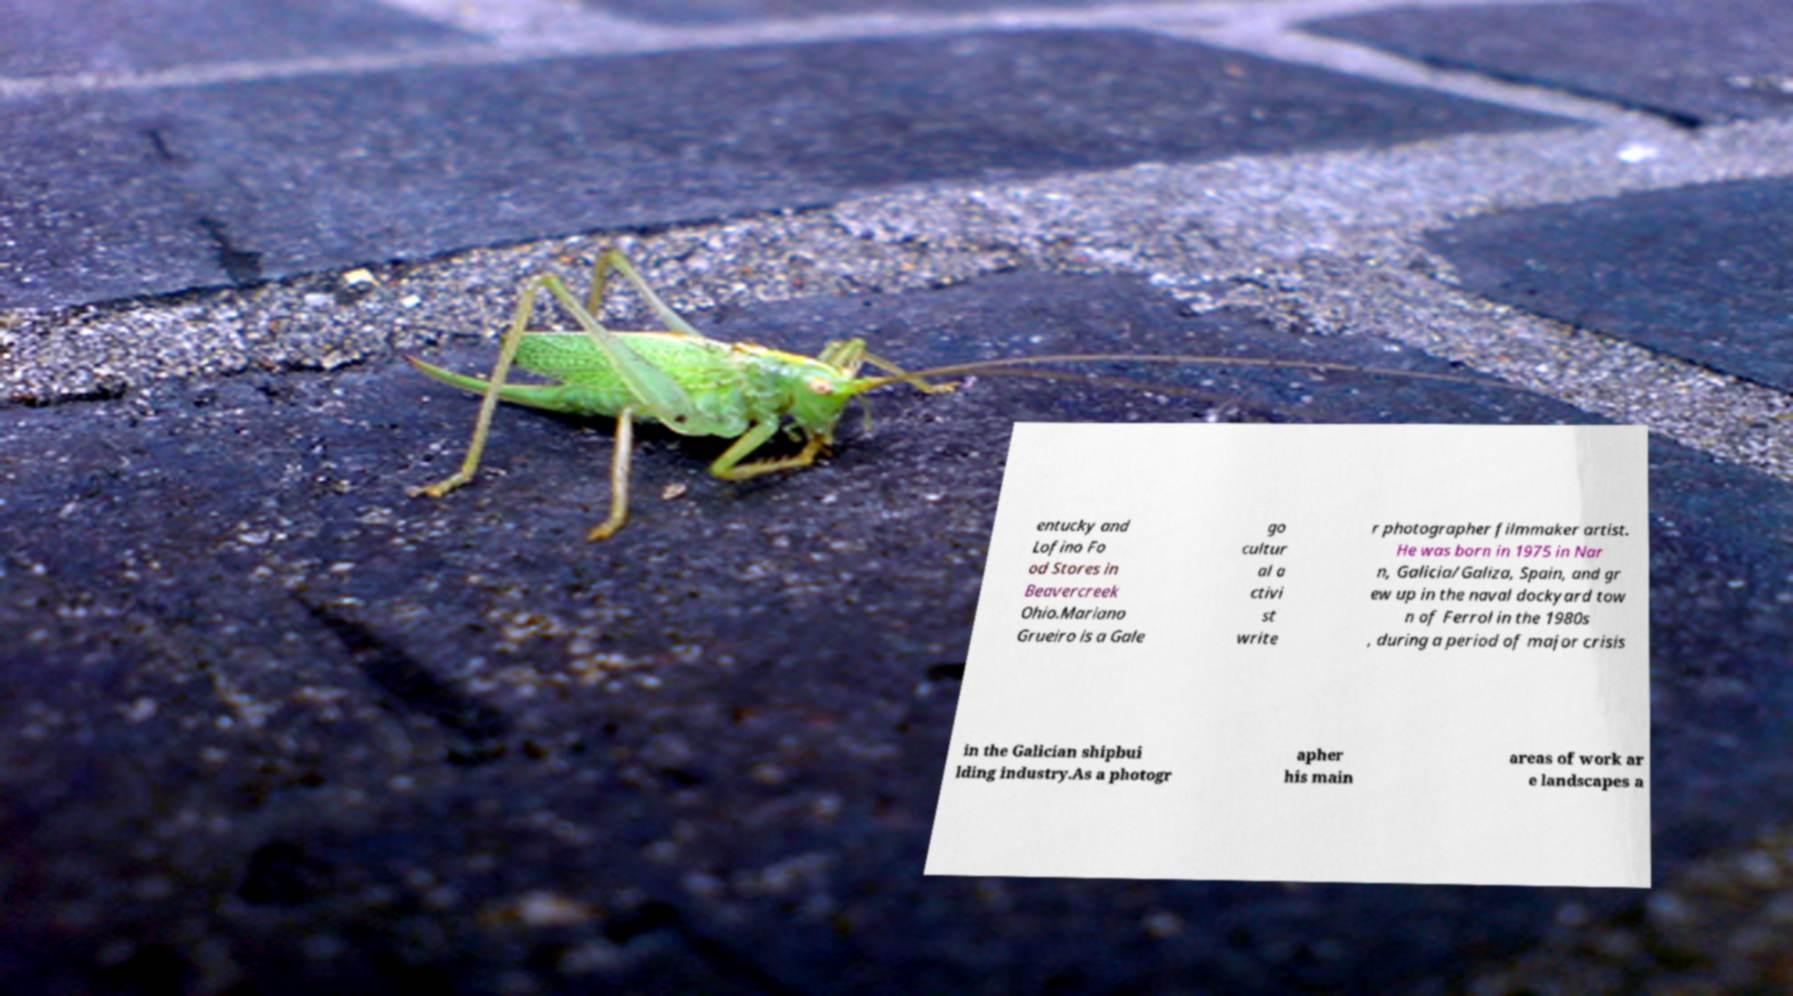For documentation purposes, I need the text within this image transcribed. Could you provide that? entucky and Lofino Fo od Stores in Beavercreek Ohio.Mariano Grueiro is a Gale go cultur al a ctivi st write r photographer filmmaker artist. He was born in 1975 in Nar n, Galicia/Galiza, Spain, and gr ew up in the naval dockyard tow n of Ferrol in the 1980s , during a period of major crisis in the Galician shipbui lding industry.As a photogr apher his main areas of work ar e landscapes a 